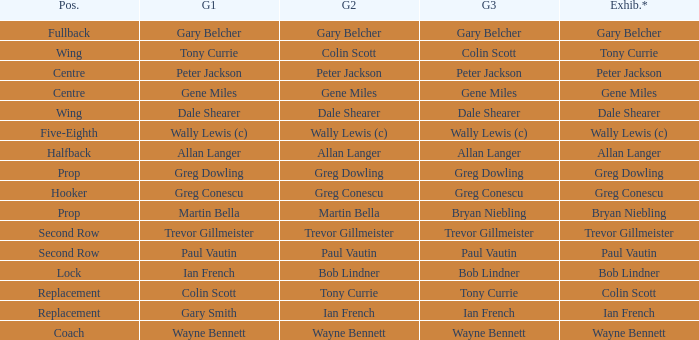What position has colin scott as game 1? Replacement. 